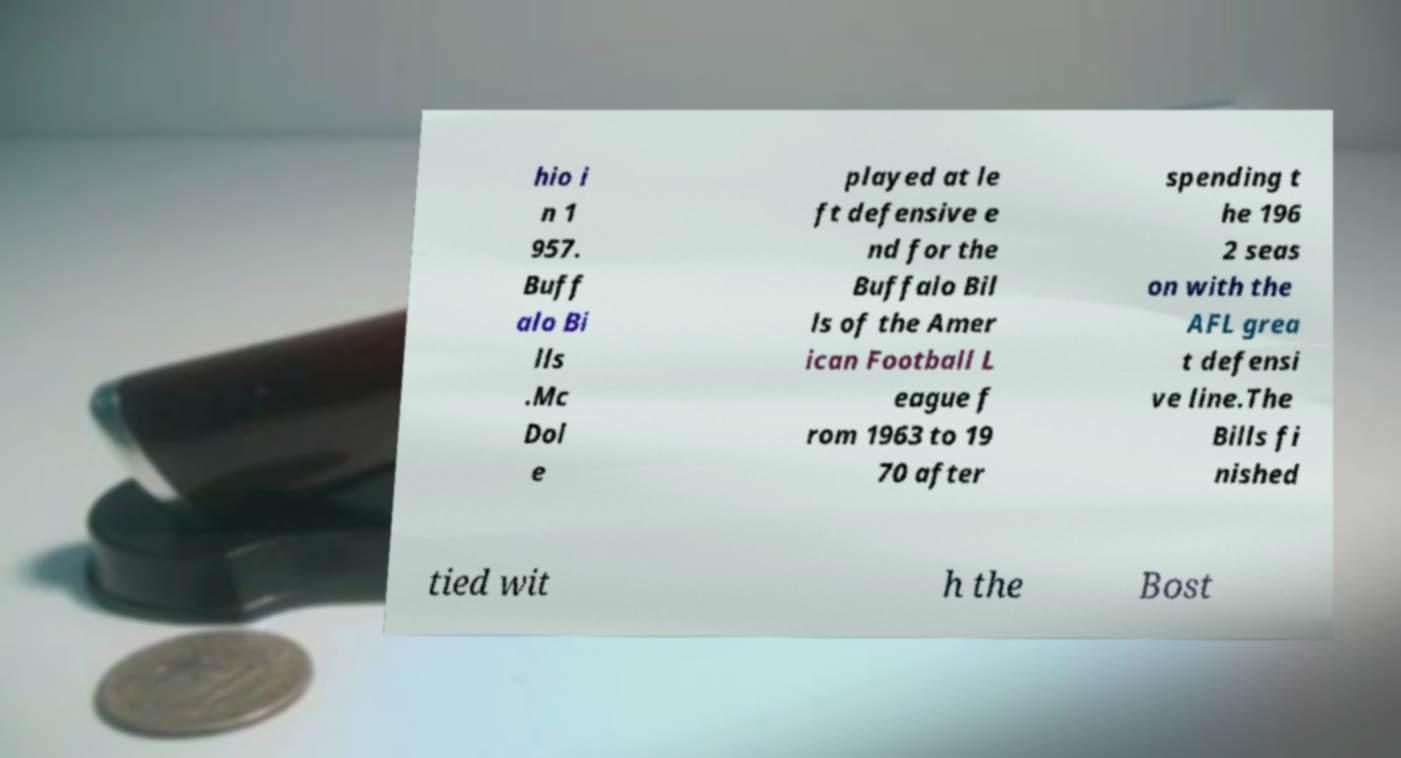Could you extract and type out the text from this image? hio i n 1 957. Buff alo Bi lls .Mc Dol e played at le ft defensive e nd for the Buffalo Bil ls of the Amer ican Football L eague f rom 1963 to 19 70 after spending t he 196 2 seas on with the AFL grea t defensi ve line.The Bills fi nished tied wit h the Bost 